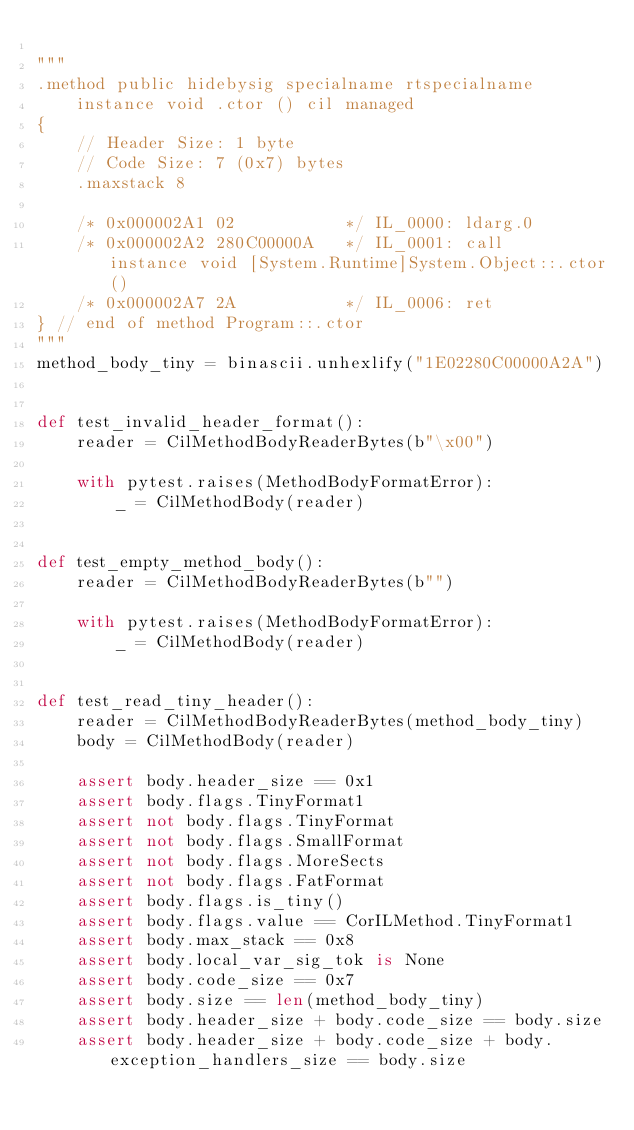Convert code to text. <code><loc_0><loc_0><loc_500><loc_500><_Python_>
"""
.method public hidebysig specialname rtspecialname
    instance void .ctor () cil managed
{
    // Header Size: 1 byte
    // Code Size: 7 (0x7) bytes
    .maxstack 8

    /* 0x000002A1 02           */ IL_0000: ldarg.0
    /* 0x000002A2 280C00000A   */ IL_0001: call      instance void [System.Runtime]System.Object::.ctor()
    /* 0x000002A7 2A           */ IL_0006: ret
} // end of method Program::.ctor
"""
method_body_tiny = binascii.unhexlify("1E02280C00000A2A")


def test_invalid_header_format():
    reader = CilMethodBodyReaderBytes(b"\x00")

    with pytest.raises(MethodBodyFormatError):
        _ = CilMethodBody(reader)


def test_empty_method_body():
    reader = CilMethodBodyReaderBytes(b"")

    with pytest.raises(MethodBodyFormatError):
        _ = CilMethodBody(reader)


def test_read_tiny_header():
    reader = CilMethodBodyReaderBytes(method_body_tiny)
    body = CilMethodBody(reader)

    assert body.header_size == 0x1
    assert body.flags.TinyFormat1
    assert not body.flags.TinyFormat
    assert not body.flags.SmallFormat
    assert not body.flags.MoreSects
    assert not body.flags.FatFormat
    assert body.flags.is_tiny()
    assert body.flags.value == CorILMethod.TinyFormat1
    assert body.max_stack == 0x8
    assert body.local_var_sig_tok is None
    assert body.code_size == 0x7
    assert body.size == len(method_body_tiny)
    assert body.header_size + body.code_size == body.size
    assert body.header_size + body.code_size + body.exception_handlers_size == body.size</code> 